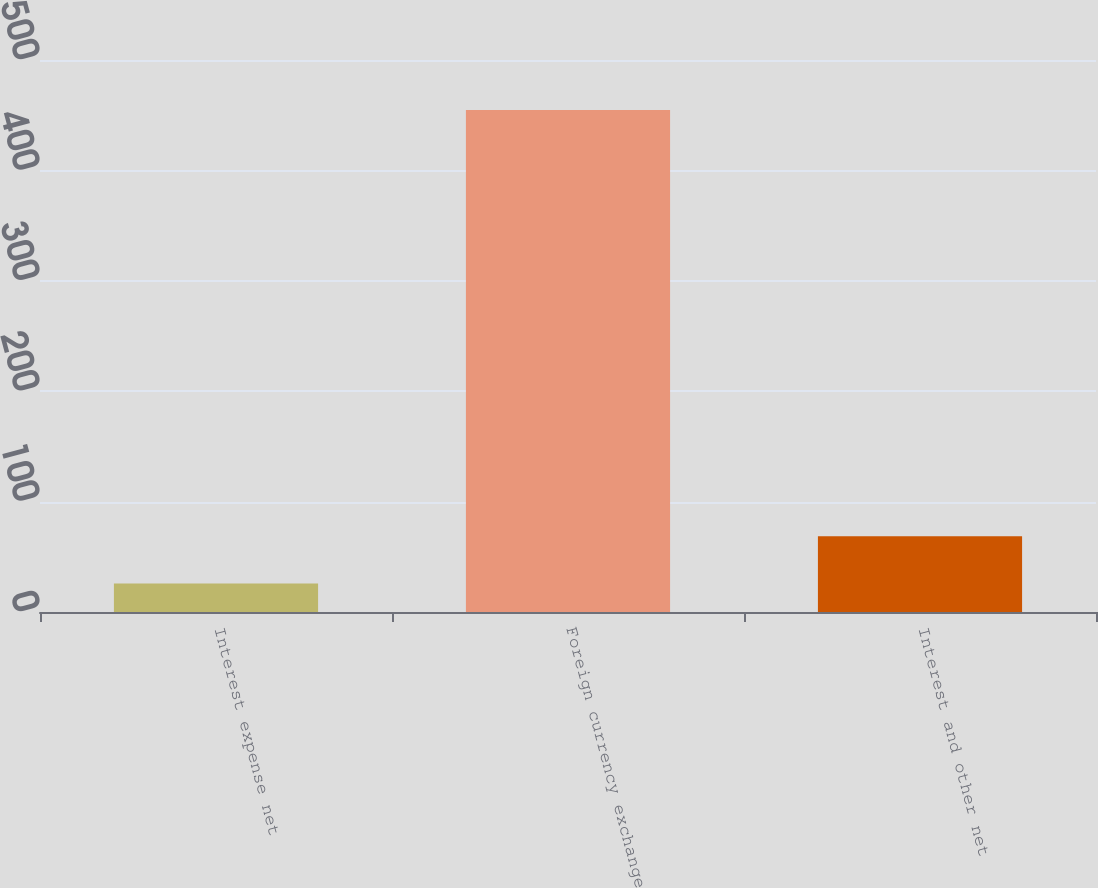<chart> <loc_0><loc_0><loc_500><loc_500><bar_chart><fcel>Interest expense net<fcel>Foreign currency exchange<fcel>Interest and other net<nl><fcel>25.8<fcel>454.7<fcel>68.69<nl></chart> 